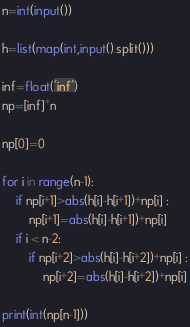<code> <loc_0><loc_0><loc_500><loc_500><_Python_>n=int(input())

h=list(map(int,input().split()))

inf=float('inf')
np=[inf]*n

np[0]=0

for i in range(n-1):
    if np[i+1]>abs(h[i]-h[i+1])+np[i] :
        np[i+1]=abs(h[i]-h[i+1])+np[i]
    if i < n-2:
        if np[i+2]>abs(h[i]-h[i+2])+np[i] :
            np[i+2]=abs(h[i]-h[i+2])+np[i]

print(int(np[n-1]))
</code> 